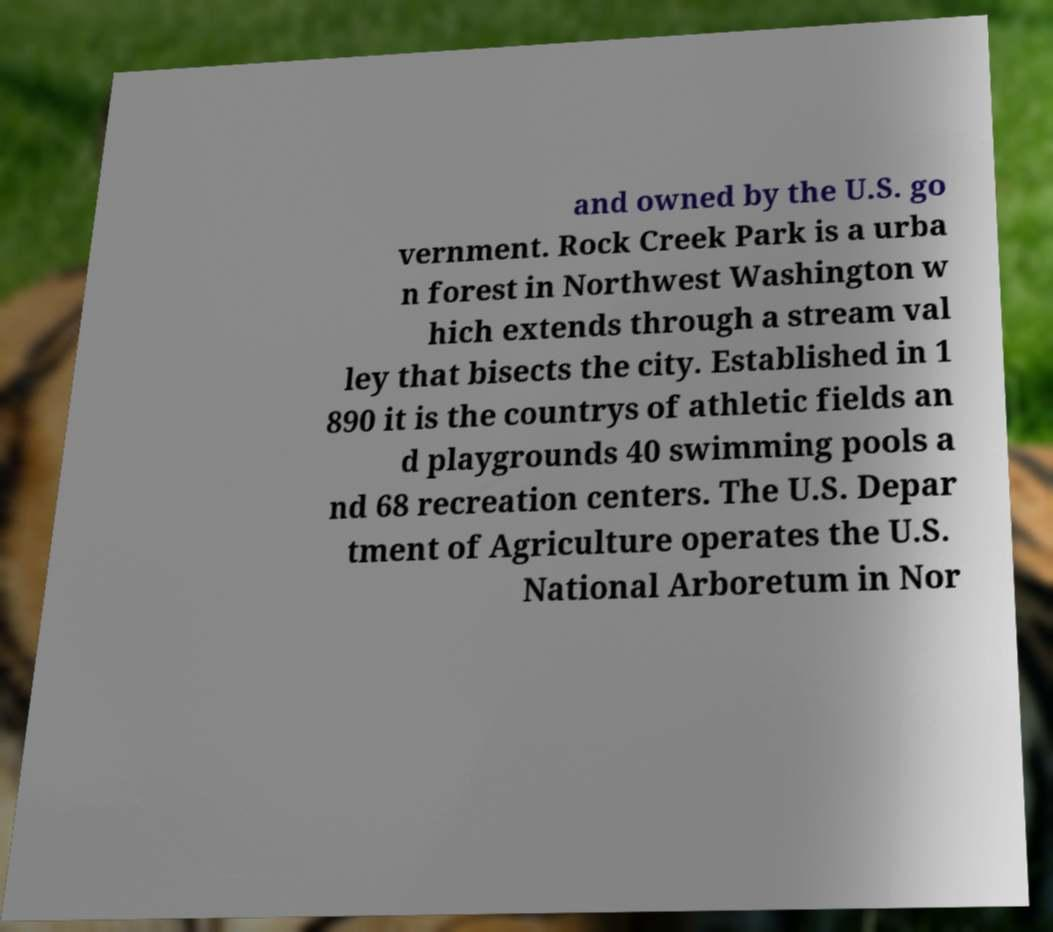Please identify and transcribe the text found in this image. and owned by the U.S. go vernment. Rock Creek Park is a urba n forest in Northwest Washington w hich extends through a stream val ley that bisects the city. Established in 1 890 it is the countrys of athletic fields an d playgrounds 40 swimming pools a nd 68 recreation centers. The U.S. Depar tment of Agriculture operates the U.S. National Arboretum in Nor 